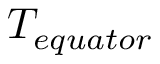Convert formula to latex. <formula><loc_0><loc_0><loc_500><loc_500>T _ { e q u a t o r }</formula> 